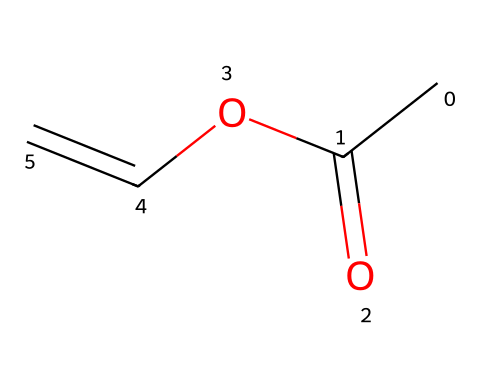How many carbon atoms are in vinyl acetate? The SMILES representation indicates the presence of 4 carbon atoms (CC(=O)OC=C shows two Cs in the beginning, one in the carbonyl group, and one in the alkene).
Answer: 4 What functional group is present in this compound? The structure contains a carbonyl group (C=O) as part of an ester (O-C), indicating that the functional group is an ester.
Answer: ester What type of isomerism can vinyl acetate exhibit? Since vinyl acetate has a double bond (C=C), it can exhibit geometric (cis/trans) isomerism.
Answer: geometric isomerism How many double bonds are in vinyl acetate? By analyzing the structure based on the SMILES, it shows one double bond between the two carbon atoms in the alkenyl part (C=C).
Answer: 1 What does the 'O' in the structure represent? The 'O' symbolizes an oxygen atom, specifically as part of the ester functional group connecting the carbon chain to the carbonyl group (C=O).
Answer: oxygen What type of bond connects the carbonyl group to the alkene? The carbonyl group (C=O) is linked to the alkene through a single covalent bond to the oxygen atom in the ester part of the molecule.
Answer: single bond 